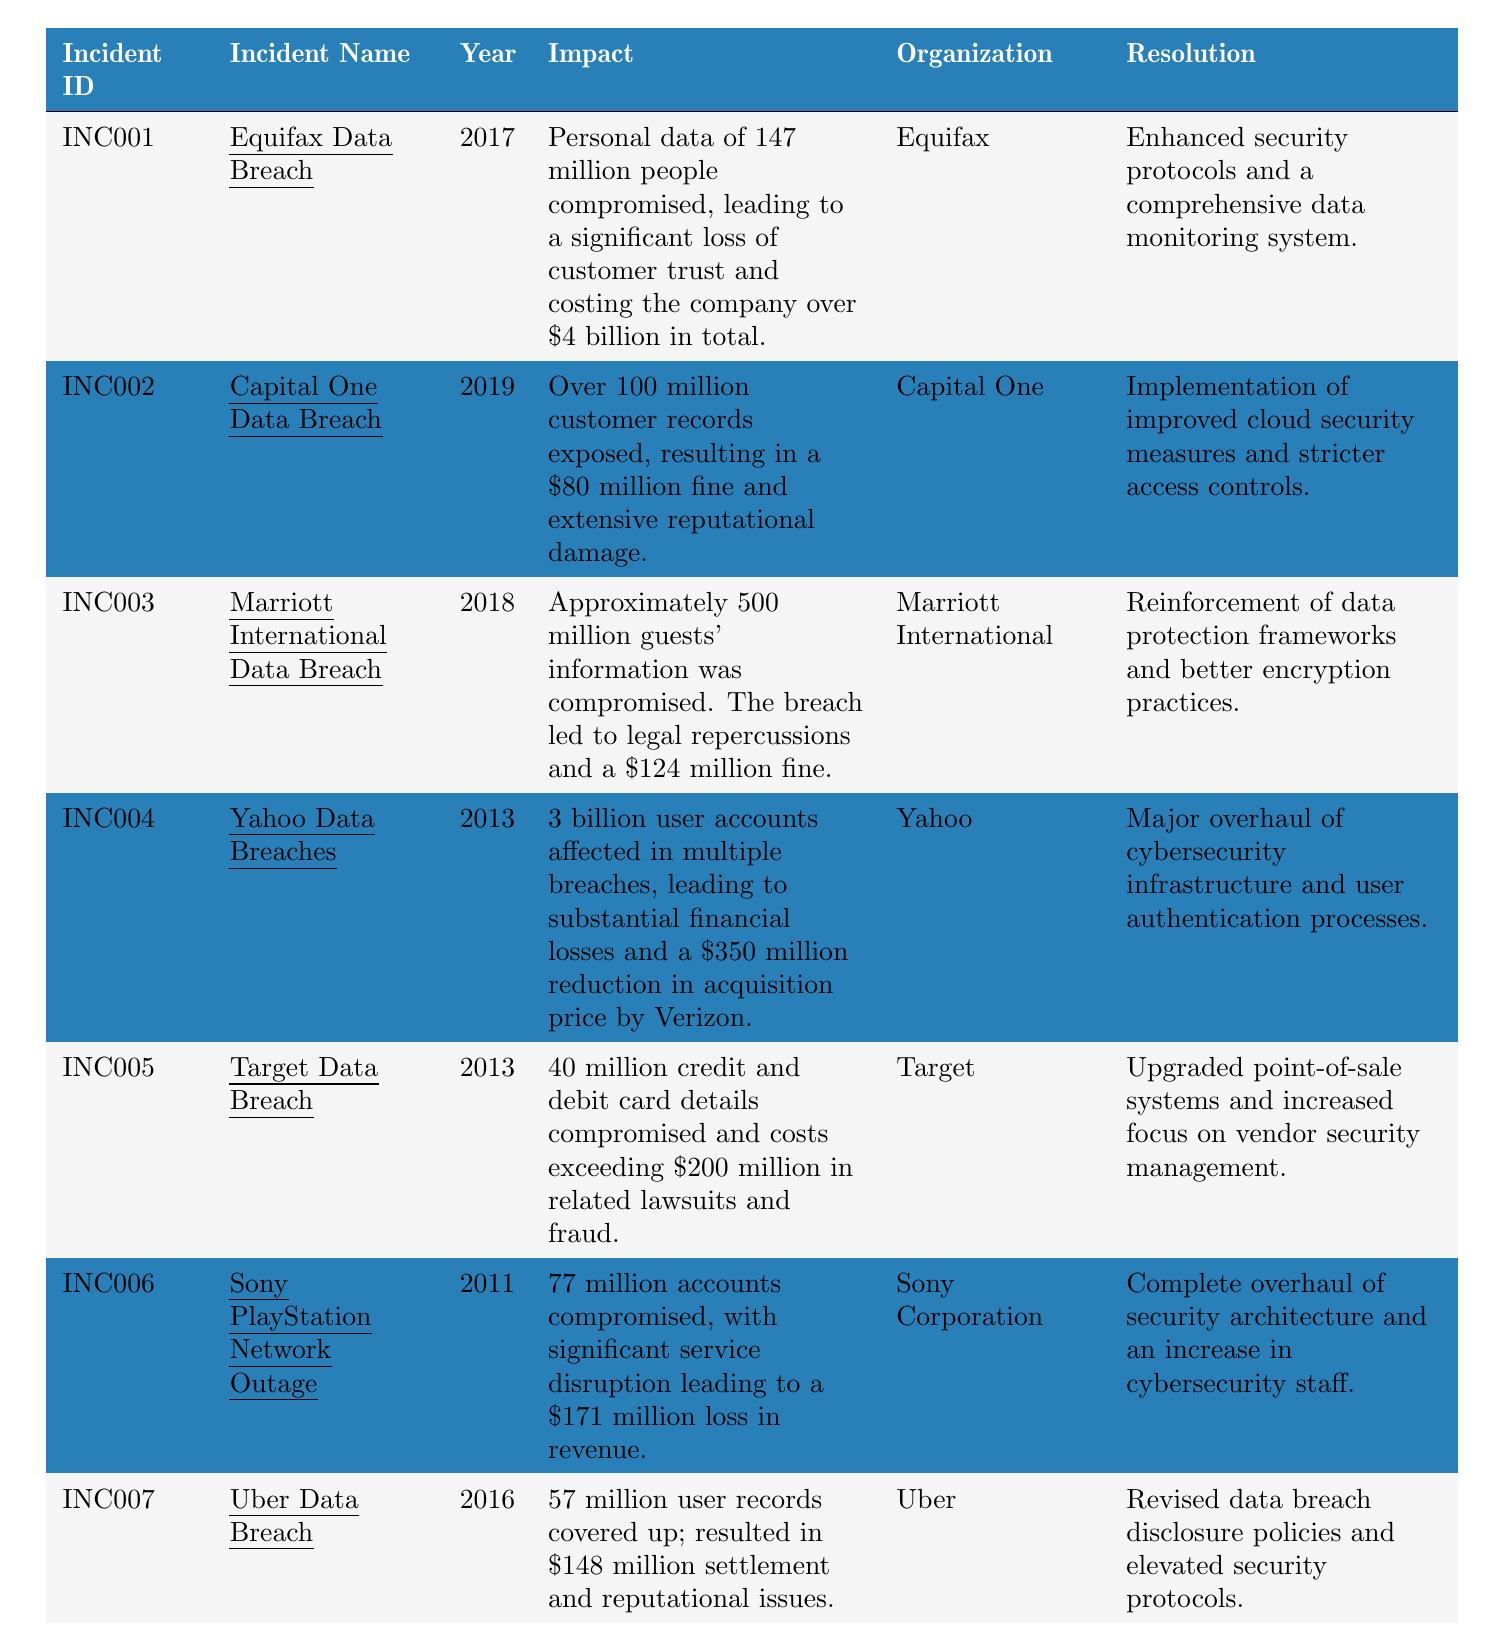What was the financial impact of the Equifax Data Breach? The impact of the Equifax Data Breach in 2017 is described in the table as leading to a loss of over $4 billion.
Answer: Over $4 billion How many user accounts were compromised in the Sony PlayStation Network Outage? According to the table, 77 million accounts were compromised during the Sony PlayStation Network Outage.
Answer: 77 million Which organization suffered the largest data breach in terms of affected records? Comparing the incidents, the Yahoo Data Breaches affected 3 billion user accounts, which is the highest among all incidents listed in the table.
Answer: Yahoo What year did the Capital One Data Breach occur? The table indicates that the Capital One Data Breach occurred in 2019.
Answer: 2019 Did the Marriott International Data Breach lead to any legal repercussions? Yes, the table states that the Marriott Data Breach led to legal repercussions along with a $124 million fine.
Answer: Yes What is the total monetary cost for the breaches mentioned in 2013? The costs for the breaches in 2013 are $350 million (Yahoo) and over $200 million (Target). Summing these gives $350 million + $200 million = $550 million for 2013.
Answer: $550 million Based on the table, did any organization experience a data breach before 2013? Yes, the Sony PlayStation Network Outage occurred in 2011 as per the data in the table.
Answer: Yes What resolution was implemented by Equifax after their data breach? The table mentions that Equifax enhanced security protocols and established a comprehensive data monitoring system post-breach.
Answer: Enhanced security protocols and monitoring system Which incident resulted in the largest fine mentioned in the table? The Marriott International Data Breach resulted in a fine of $124 million, which is the largest fine indicated among the incidents listed.
Answer: $124 million How many incidents led to changes in data security protocols? Upon reviewing the resolutions listed for each incident, all the incidents (7 total) resulted in enhanced security measures or changes in protocols.
Answer: 7 